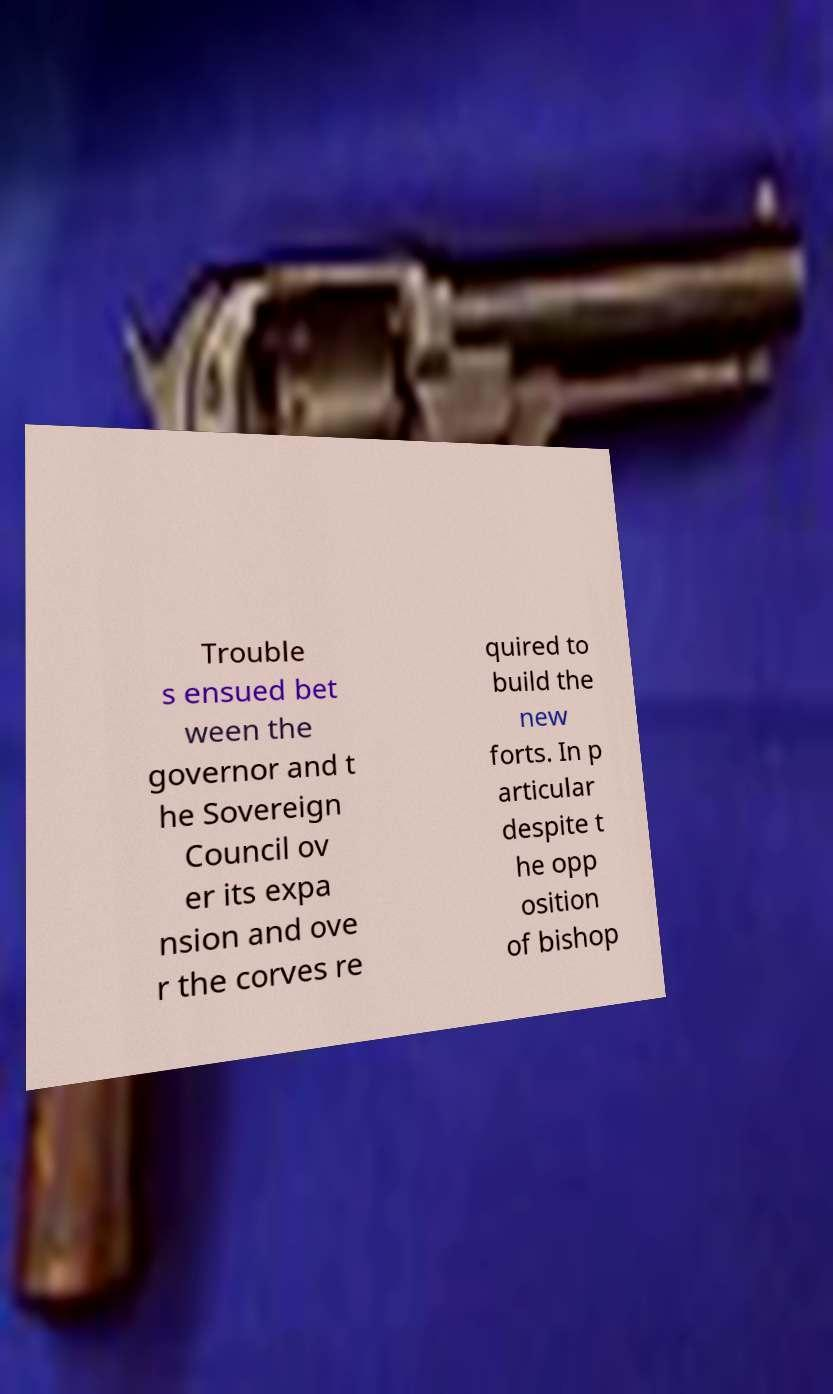What messages or text are displayed in this image? I need them in a readable, typed format. Trouble s ensued bet ween the governor and t he Sovereign Council ov er its expa nsion and ove r the corves re quired to build the new forts. In p articular despite t he opp osition of bishop 